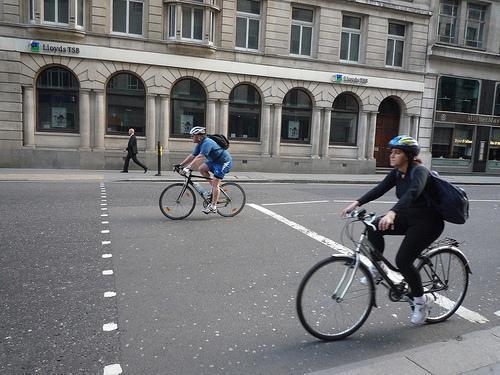How many people are on bikes?
Give a very brief answer. 2. How many people are walking?
Give a very brief answer. 1. How many wheels does each bike have?
Give a very brief answer. 2. 